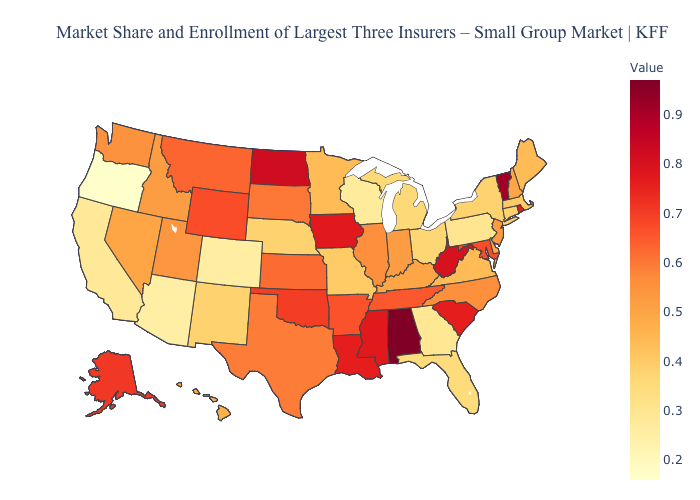Among the states that border Missouri , does Tennessee have the highest value?
Write a very short answer. No. Among the states that border Utah , does New Mexico have the highest value?
Answer briefly. No. Does Alaska have the highest value in the West?
Write a very short answer. Yes. Which states hav the highest value in the South?
Keep it brief. Alabama. Among the states that border Indiana , which have the lowest value?
Be succinct. Michigan. Does the map have missing data?
Short answer required. No. Which states have the lowest value in the USA?
Answer briefly. Oregon. Among the states that border Utah , does Arizona have the lowest value?
Concise answer only. Yes. Does the map have missing data?
Short answer required. No. 